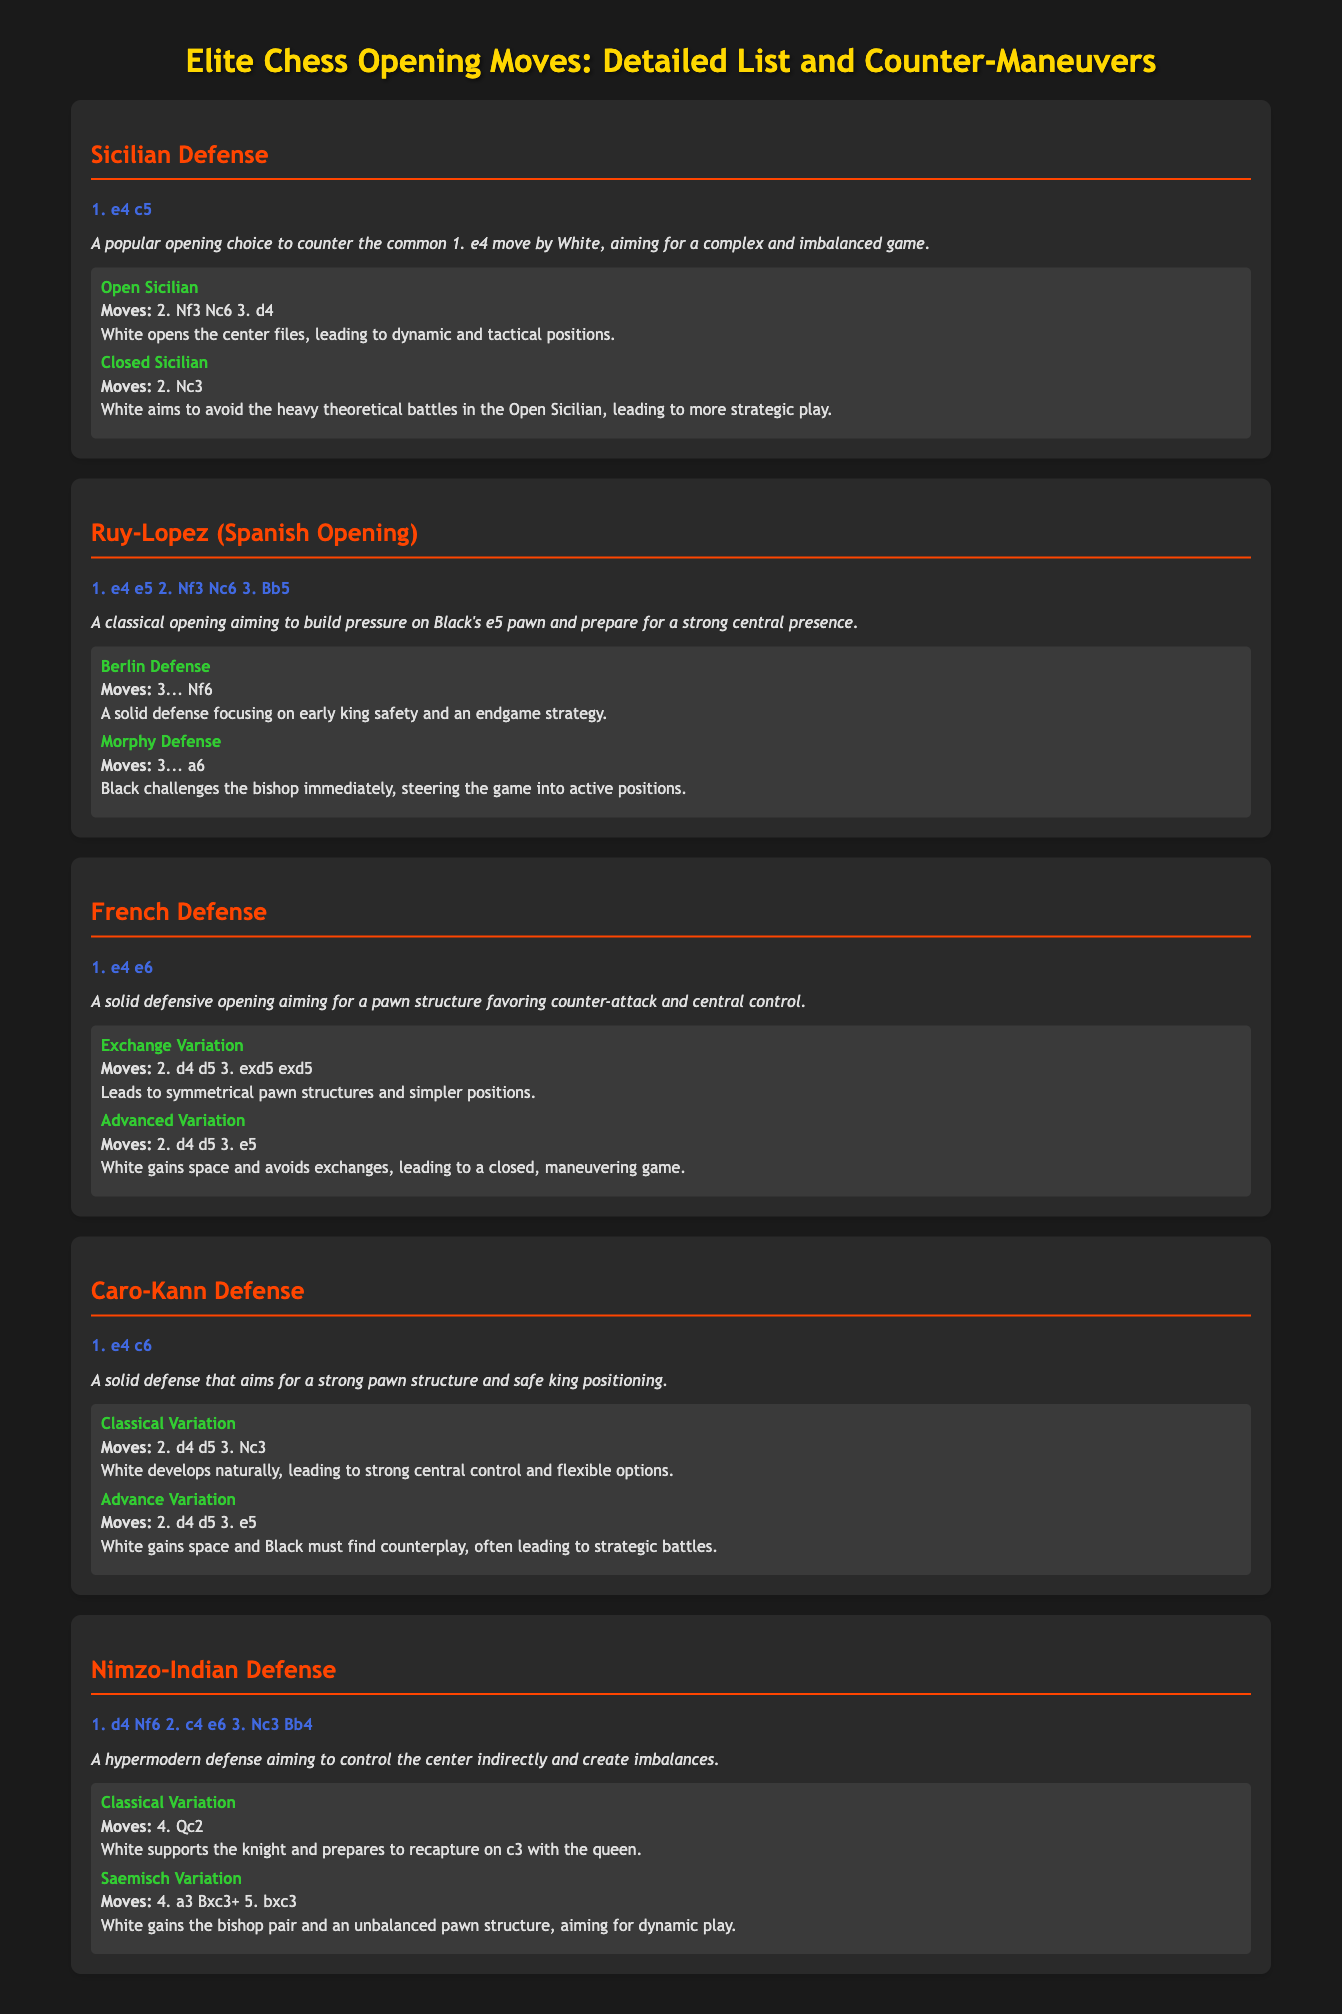What is the first move of the Sicilian Defense? The first move of the Sicilian Defense is listed as 1. e4 c5.
Answer: 1. e4 c5 What color is the title of the section on the Ruy-Lopez? The section title for the Ruy-Lopez is in the color #ff4500 according to the style definitions.
Answer: #ff4500 Which opening aims for a strong central presence? The description for the Ruy-Lopez indicates an aim for a strong central presence.
Answer: Ruy-Lopez How many counter-moves are mentioned for the French Defense? The document lists two counter-moves for the French Defense, providing various options.
Answer: 2 What is the name of the first counter-move of the Caro-Kann Defense? The document explicitly states that the first counter-move of the Caro-Kann Defense is the Classical Variation.
Answer: Classical Variation How does the description of the Nimzo-Indian Defense characterize its strategy? The description of the Nimzo-Indian Defense mentions it aims to control the center indirectly.
Answer: Control the center indirectly What is the specific move sequence for the Open Sicilian counter-move? The Open Sicilian is specified with a move sequence of 2. Nf3 Nc6 3. d4.
Answer: 2. Nf3 Nc6 3. d4 Which opening move is characterized by a symmetrical pawn structure? The Exchange Variation of the French Defense is associated with symmetrical pawn structures.
Answer: Exchange Variation What color is used for the description text in the document? The description text is styled in italic and has a color value of #e0e0e0 as per the document's style.
Answer: #e0e0e0 